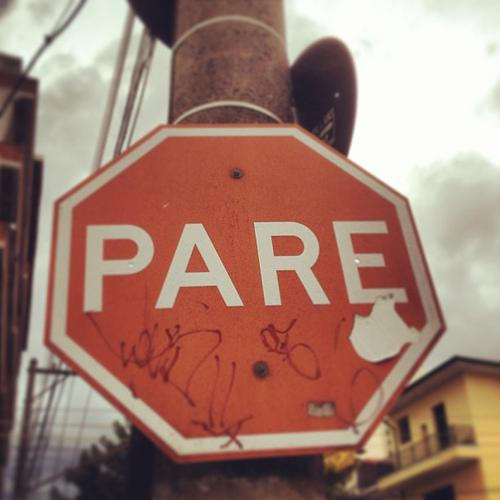Question: what does it say on the sign?
Choices:
A. Pare.
B. Stop.
C. Caution.
D. Yield.
Answer with the letter. Answer: A Question: who is in the photo?
Choices:
A. Man.
B. Noone.
C. Woman.
D. Child.
Answer with the letter. Answer: B Question: how is sign attached to pole?
Choices:
A. Nails.
B. Staples.
C. Screws.
D. Tape.
Answer with the letter. Answer: C Question: what does pare probably mean base on the color and shape of the sign?
Choices:
A. Wait.
B. Don't go.
C. Do not proceed.
D. Stop.
Answer with the letter. Answer: D 